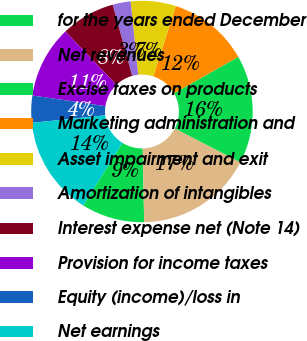<chart> <loc_0><loc_0><loc_500><loc_500><pie_chart><fcel>for the years ended December<fcel>Net revenues<fcel>Excise taxes on products<fcel>Marketing administration and<fcel>Asset impairment and exit<fcel>Amortization of intangibles<fcel>Interest expense net (Note 14)<fcel>Provision for income taxes<fcel>Equity (income)/loss in<fcel>Net earnings<nl><fcel>9.21%<fcel>17.1%<fcel>15.79%<fcel>11.84%<fcel>6.58%<fcel>2.63%<fcel>7.89%<fcel>10.53%<fcel>3.95%<fcel>14.47%<nl></chart> 